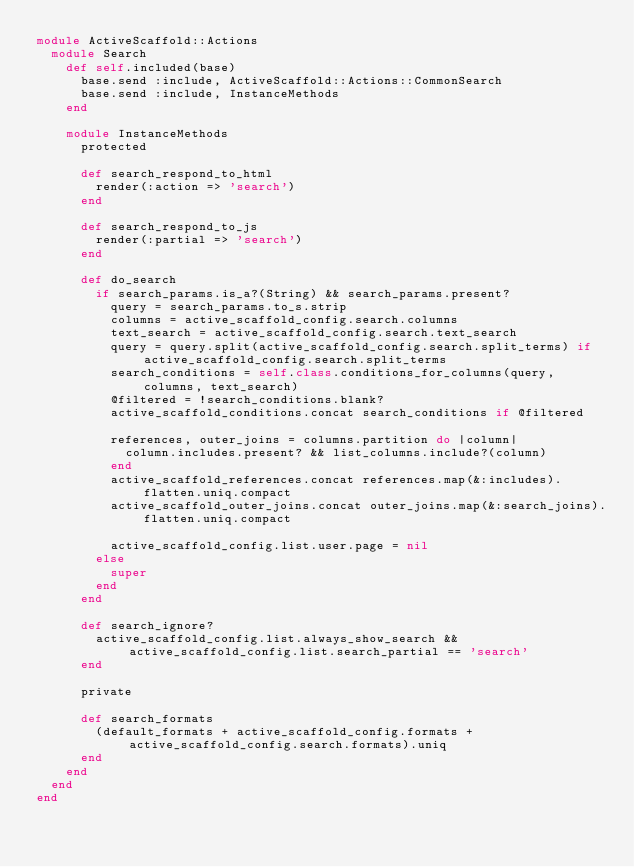<code> <loc_0><loc_0><loc_500><loc_500><_Ruby_>module ActiveScaffold::Actions
  module Search
    def self.included(base)
      base.send :include, ActiveScaffold::Actions::CommonSearch
      base.send :include, InstanceMethods
    end

    module InstanceMethods
      protected

      def search_respond_to_html
        render(:action => 'search')
      end

      def search_respond_to_js
        render(:partial => 'search')
      end

      def do_search
        if search_params.is_a?(String) && search_params.present?
          query = search_params.to_s.strip
          columns = active_scaffold_config.search.columns
          text_search = active_scaffold_config.search.text_search
          query = query.split(active_scaffold_config.search.split_terms) if active_scaffold_config.search.split_terms
          search_conditions = self.class.conditions_for_columns(query, columns, text_search)
          @filtered = !search_conditions.blank?
          active_scaffold_conditions.concat search_conditions if @filtered

          references, outer_joins = columns.partition do |column|
            column.includes.present? && list_columns.include?(column)
          end
          active_scaffold_references.concat references.map(&:includes).flatten.uniq.compact
          active_scaffold_outer_joins.concat outer_joins.map(&:search_joins).flatten.uniq.compact

          active_scaffold_config.list.user.page = nil
        else
          super
        end
      end

      def search_ignore?
        active_scaffold_config.list.always_show_search && active_scaffold_config.list.search_partial == 'search'
      end

      private

      def search_formats
        (default_formats + active_scaffold_config.formats + active_scaffold_config.search.formats).uniq
      end
    end
  end
end
</code> 